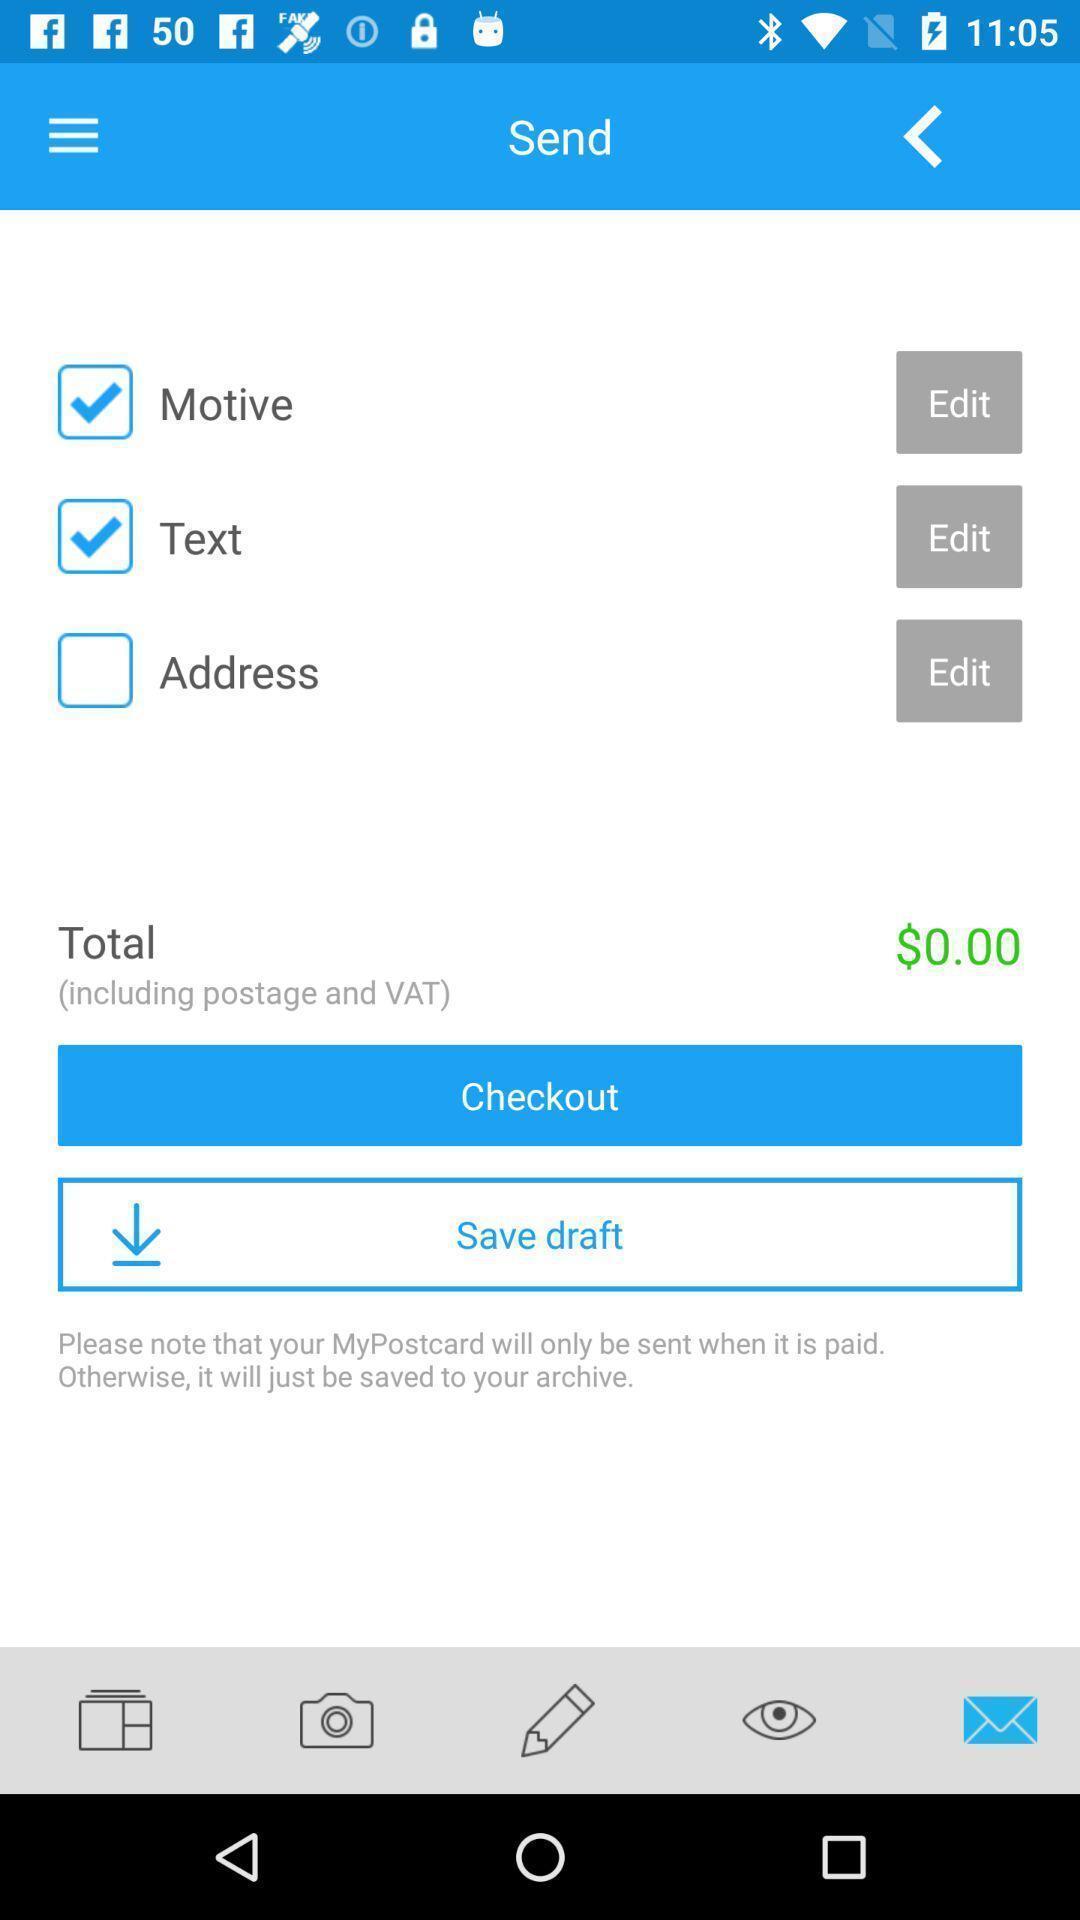Summarize the main components in this picture. Page shows to add money for sending postcards. 